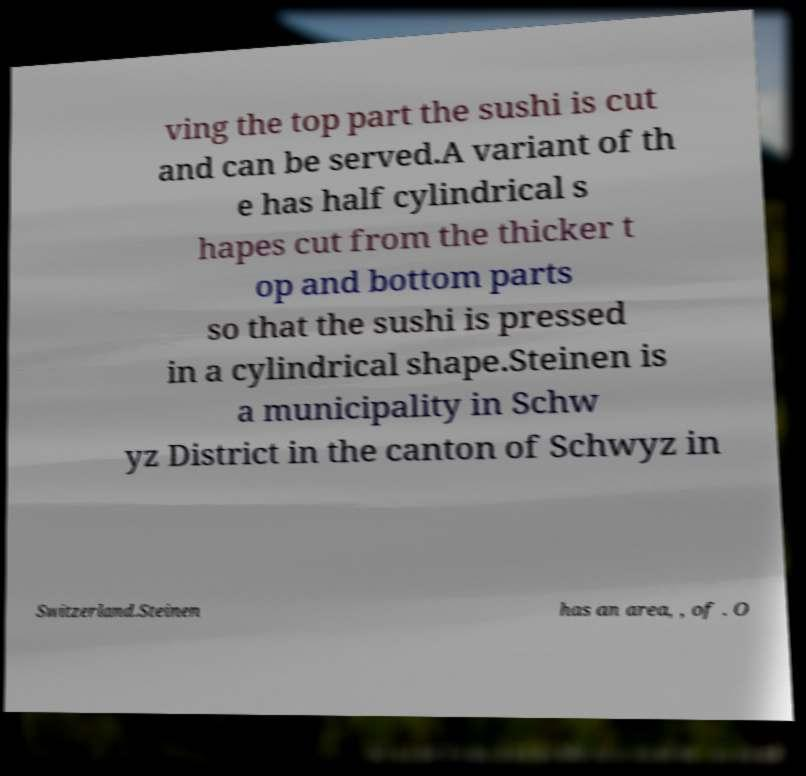Can you read and provide the text displayed in the image?This photo seems to have some interesting text. Can you extract and type it out for me? ving the top part the sushi is cut and can be served.A variant of th e has half cylindrical s hapes cut from the thicker t op and bottom parts so that the sushi is pressed in a cylindrical shape.Steinen is a municipality in Schw yz District in the canton of Schwyz in Switzerland.Steinen has an area, , of . O 